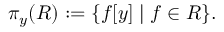Convert formula to latex. <formula><loc_0><loc_0><loc_500><loc_500>\pi _ { y } ( R ) \colon = \{ f [ y ] | f \in R \} .</formula> 